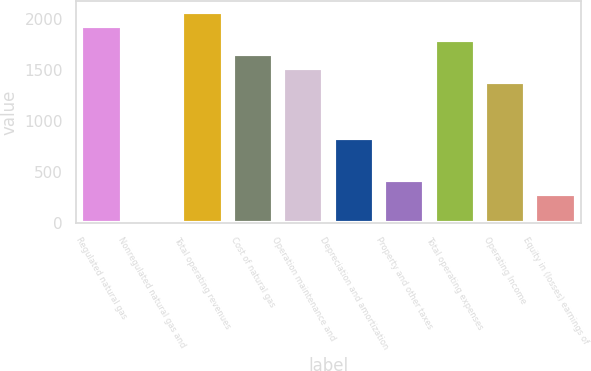<chart> <loc_0><loc_0><loc_500><loc_500><bar_chart><fcel>Regulated natural gas<fcel>Nonregulated natural gas and<fcel>Total operating revenues<fcel>Cost of natural gas<fcel>Operation maintenance and<fcel>Depreciation and amortization<fcel>Property and other taxes<fcel>Total operating expenses<fcel>Operating Income<fcel>Equity in (losses) earnings of<nl><fcel>1931.8<fcel>11<fcel>2069<fcel>1657.4<fcel>1520.2<fcel>834.2<fcel>422.6<fcel>1794.6<fcel>1383<fcel>285.4<nl></chart> 